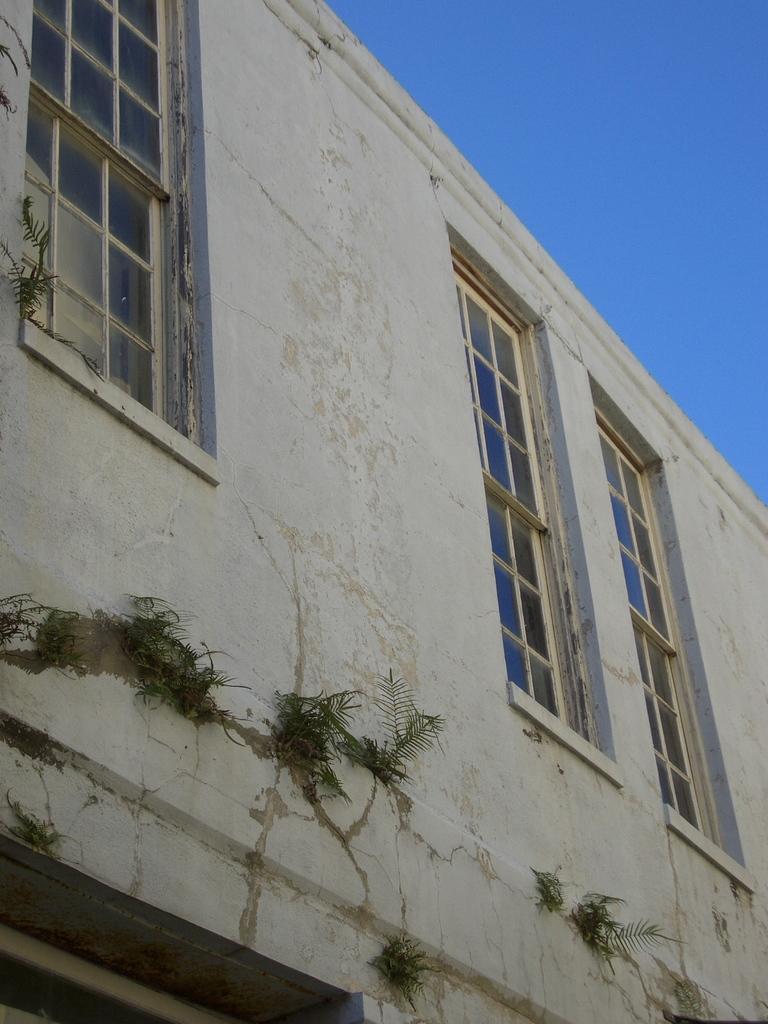Could you give a brief overview of what you see in this image? There is a building with windows. On the building there are some plants. In the background there is sky. 